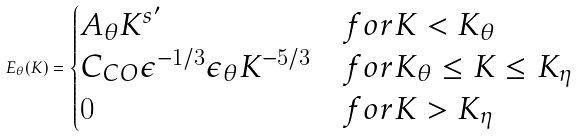Convert formula to latex. <formula><loc_0><loc_0><loc_500><loc_500>E _ { \theta } ( K ) = \begin{cases} A _ { \theta } K ^ { s ^ { \prime } } & f o r K < K _ { \theta } \\ C _ { C O } \epsilon ^ { - 1 / 3 } \epsilon _ { \theta } K ^ { - 5 / 3 } & f o r K _ { \theta } \leq K \leq K _ { \eta } \\ 0 & f o r K > K _ { \eta } \end{cases}</formula> 